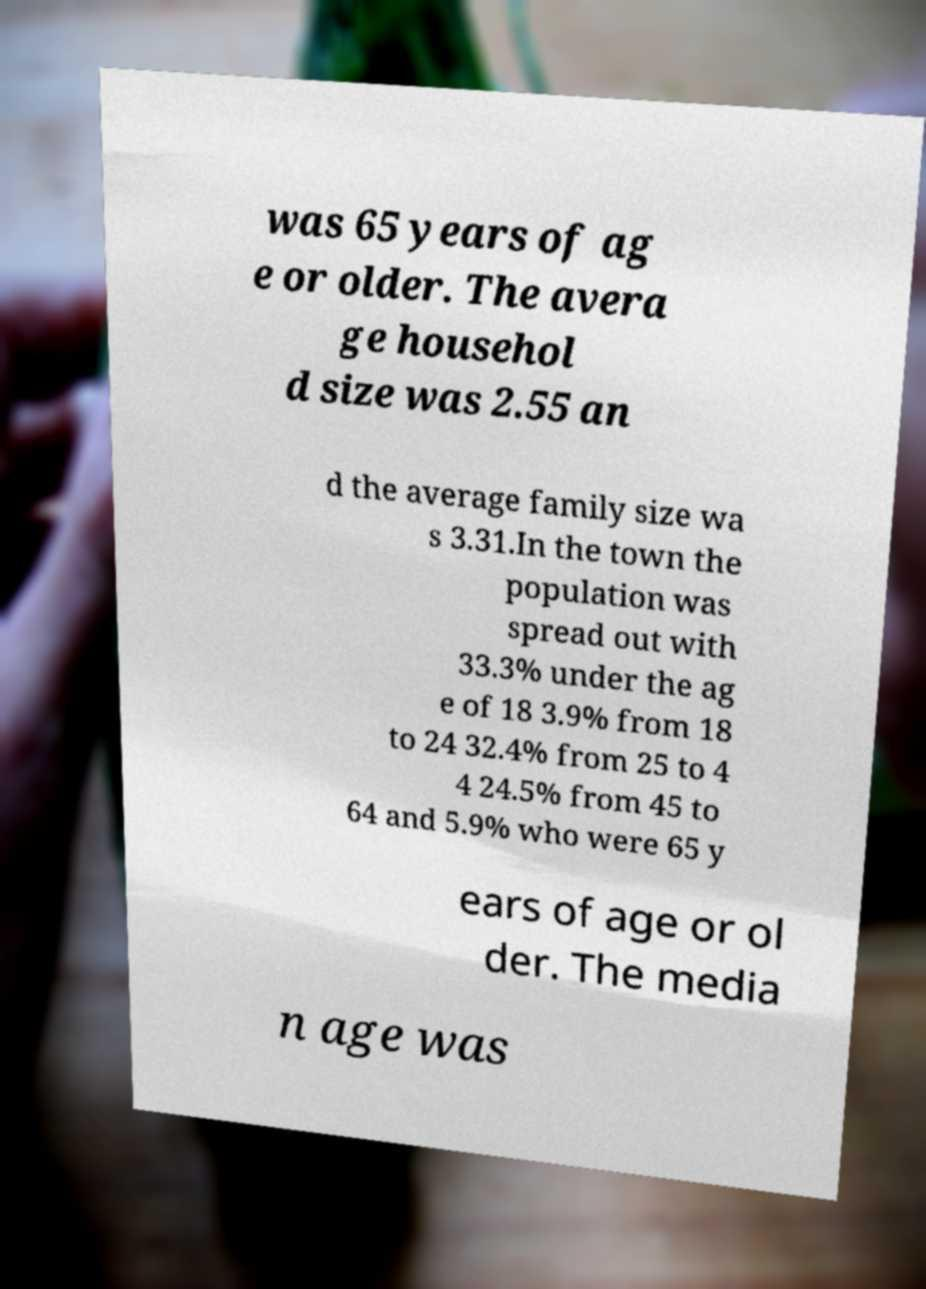Please identify and transcribe the text found in this image. was 65 years of ag e or older. The avera ge househol d size was 2.55 an d the average family size wa s 3.31.In the town the population was spread out with 33.3% under the ag e of 18 3.9% from 18 to 24 32.4% from 25 to 4 4 24.5% from 45 to 64 and 5.9% who were 65 y ears of age or ol der. The media n age was 